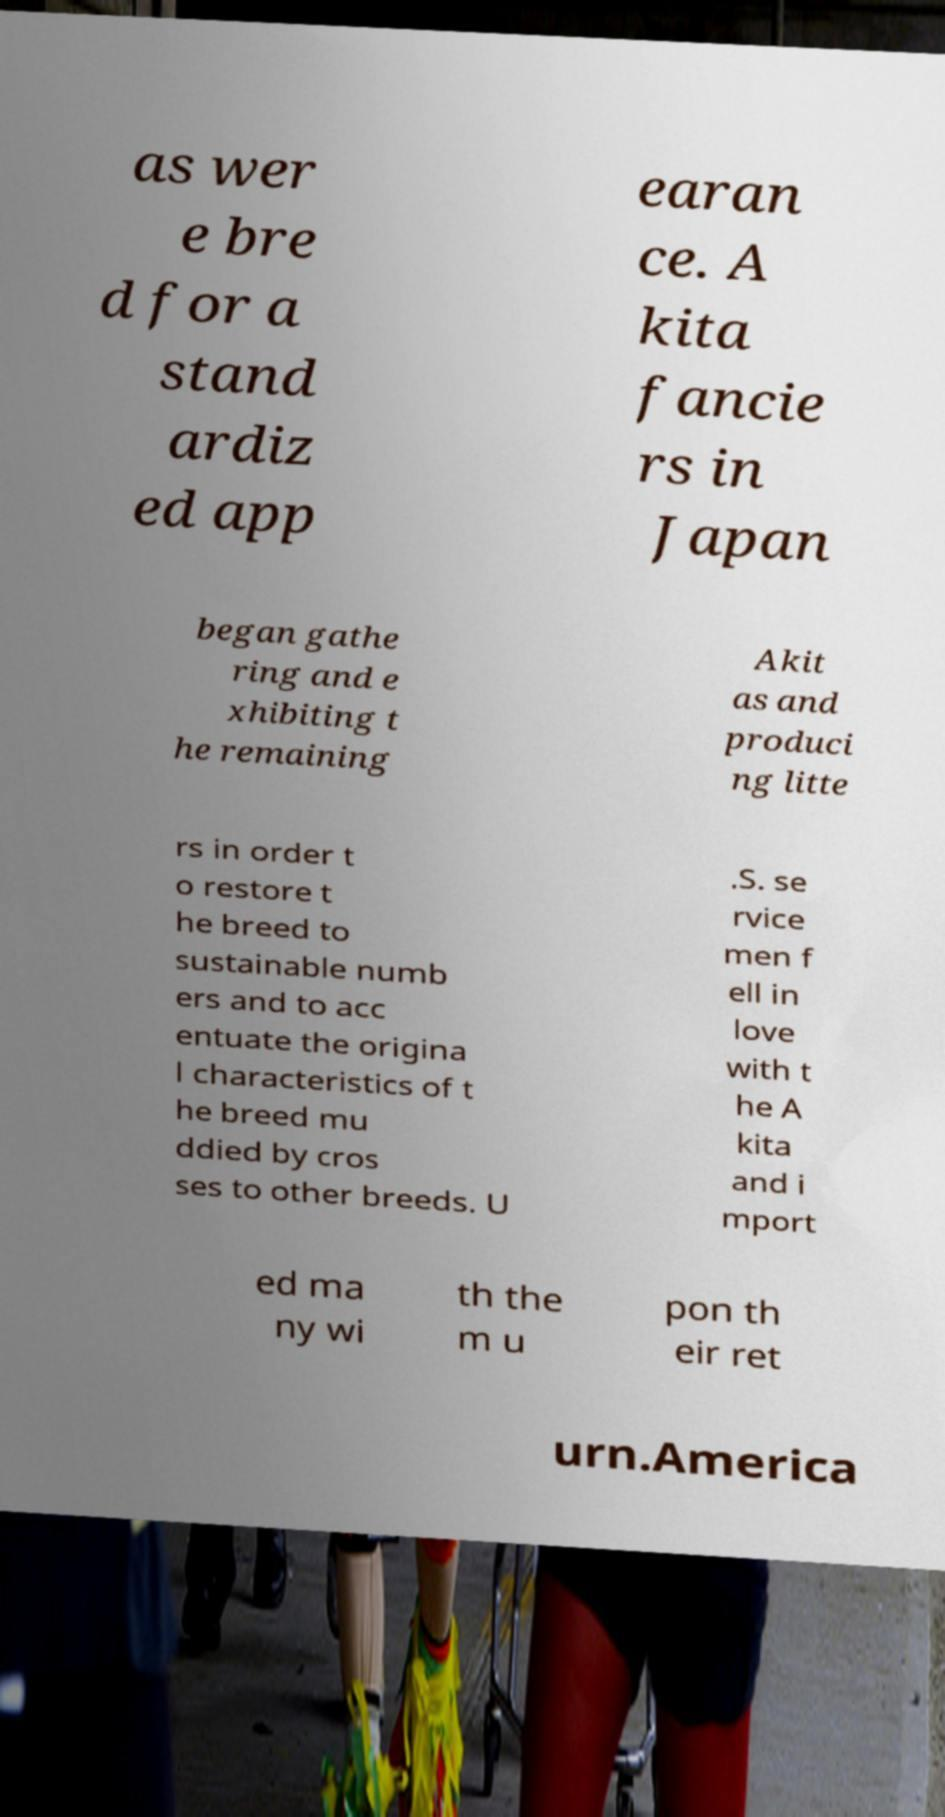Can you accurately transcribe the text from the provided image for me? as wer e bre d for a stand ardiz ed app earan ce. A kita fancie rs in Japan began gathe ring and e xhibiting t he remaining Akit as and produci ng litte rs in order t o restore t he breed to sustainable numb ers and to acc entuate the origina l characteristics of t he breed mu ddied by cros ses to other breeds. U .S. se rvice men f ell in love with t he A kita and i mport ed ma ny wi th the m u pon th eir ret urn.America 